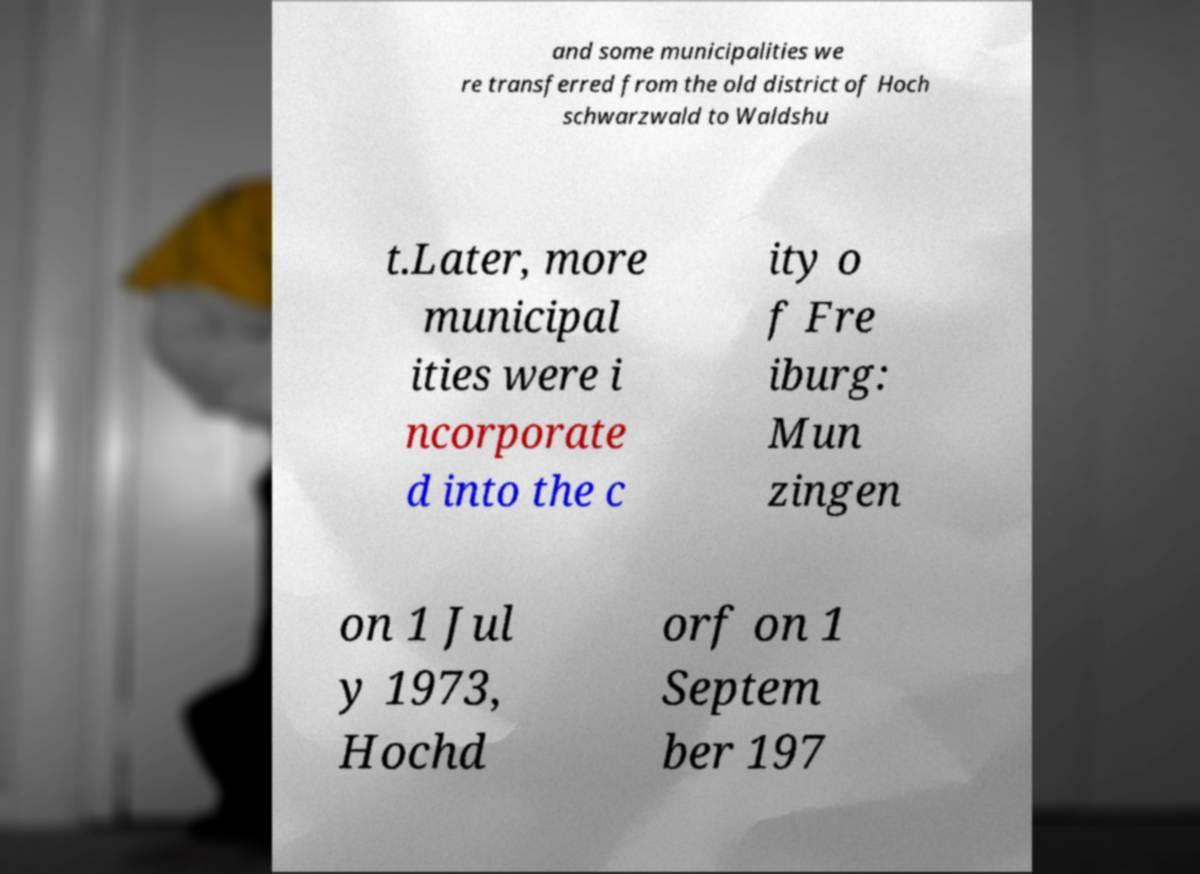Can you accurately transcribe the text from the provided image for me? and some municipalities we re transferred from the old district of Hoch schwarzwald to Waldshu t.Later, more municipal ities were i ncorporate d into the c ity o f Fre iburg: Mun zingen on 1 Jul y 1973, Hochd orf on 1 Septem ber 197 